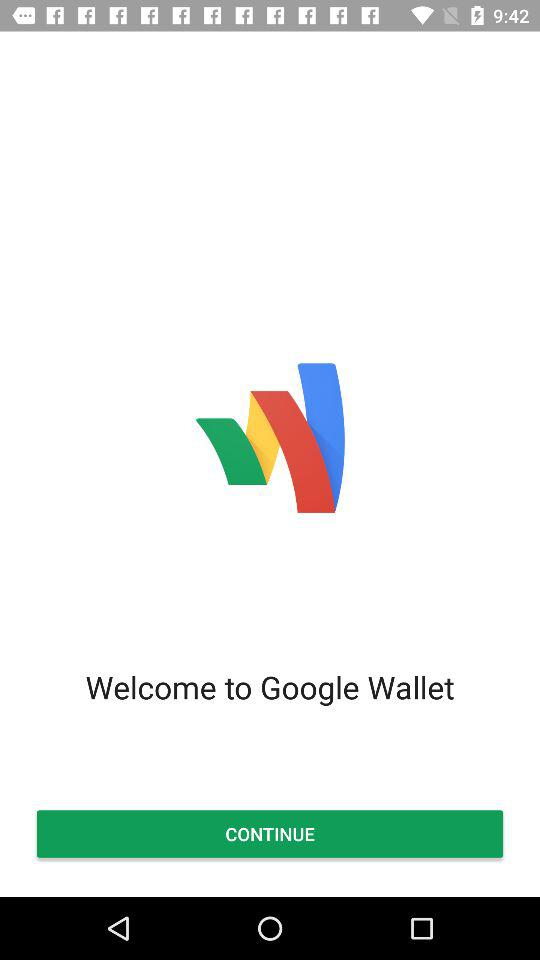What is the name of the application? The name of the application is "Google Wallet". 